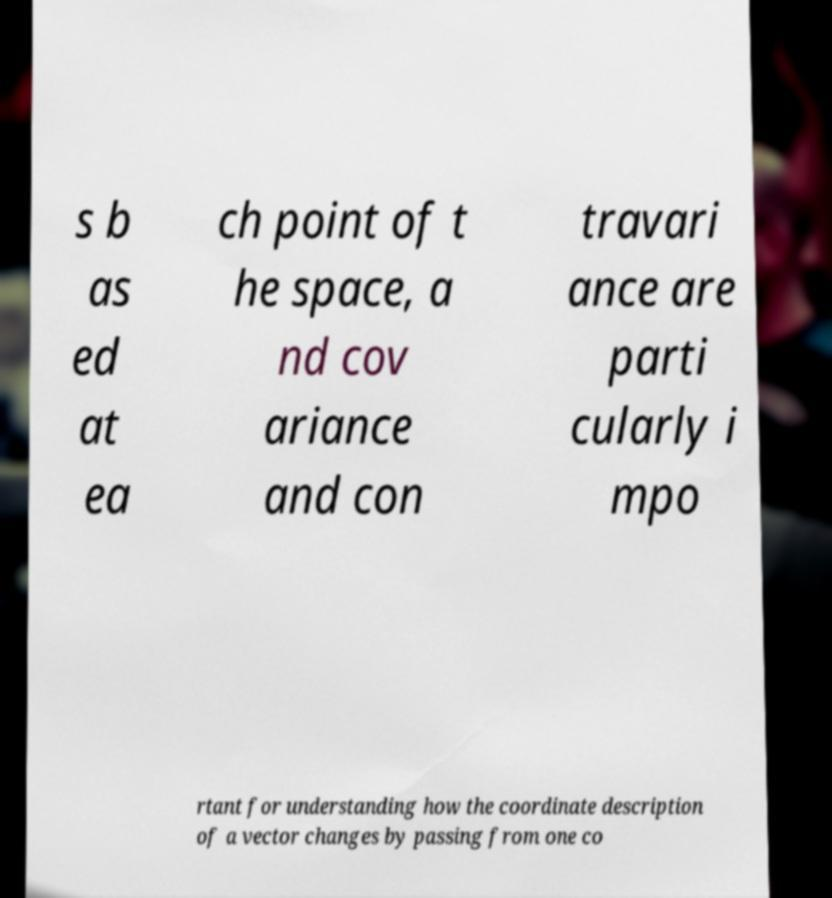Could you extract and type out the text from this image? s b as ed at ea ch point of t he space, a nd cov ariance and con travari ance are parti cularly i mpo rtant for understanding how the coordinate description of a vector changes by passing from one co 